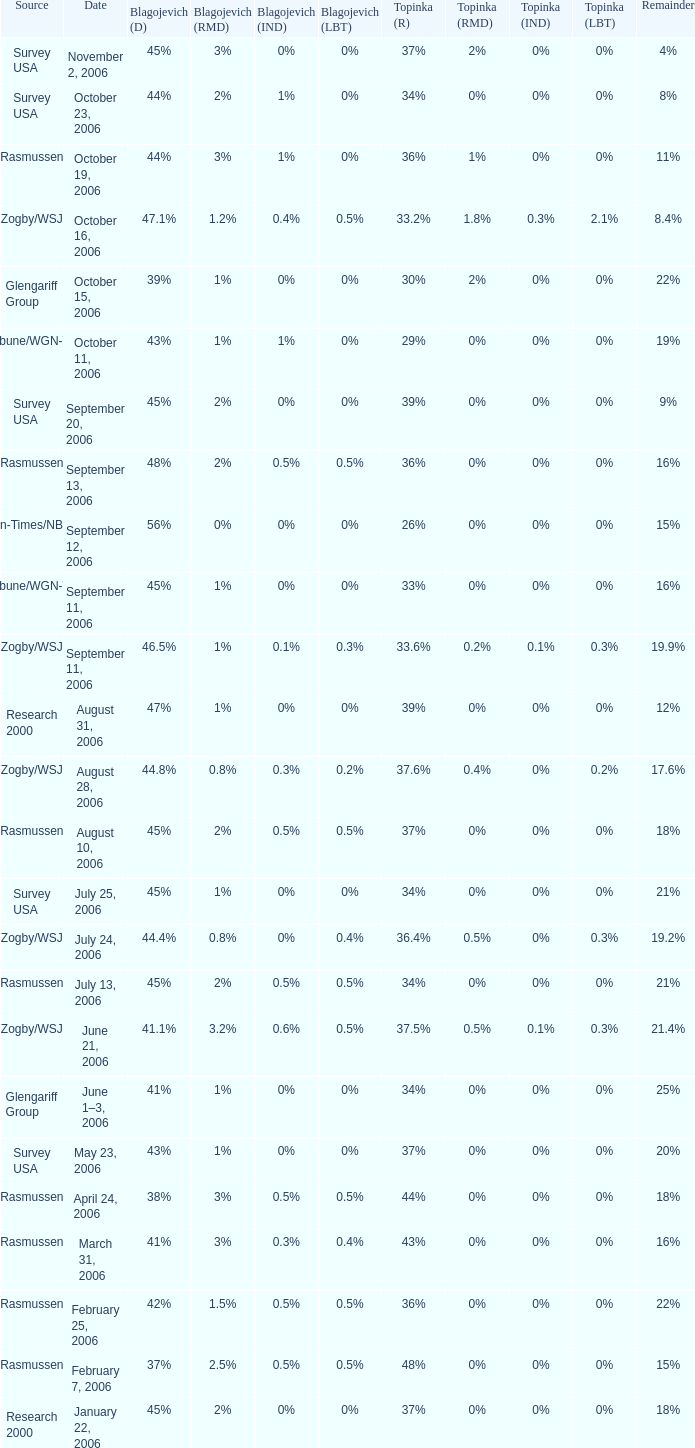2%? 47.1%. 